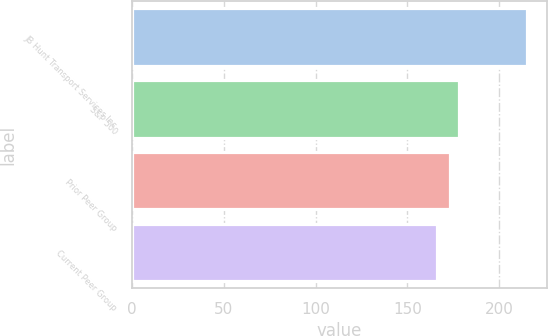Convert chart to OTSL. <chart><loc_0><loc_0><loc_500><loc_500><bar_chart><fcel>JB Hunt Transport Services Inc<fcel>S&P 500<fcel>Prior Peer Group<fcel>Current Peer Group<nl><fcel>215.08<fcel>178.29<fcel>173.24<fcel>166.23<nl></chart> 